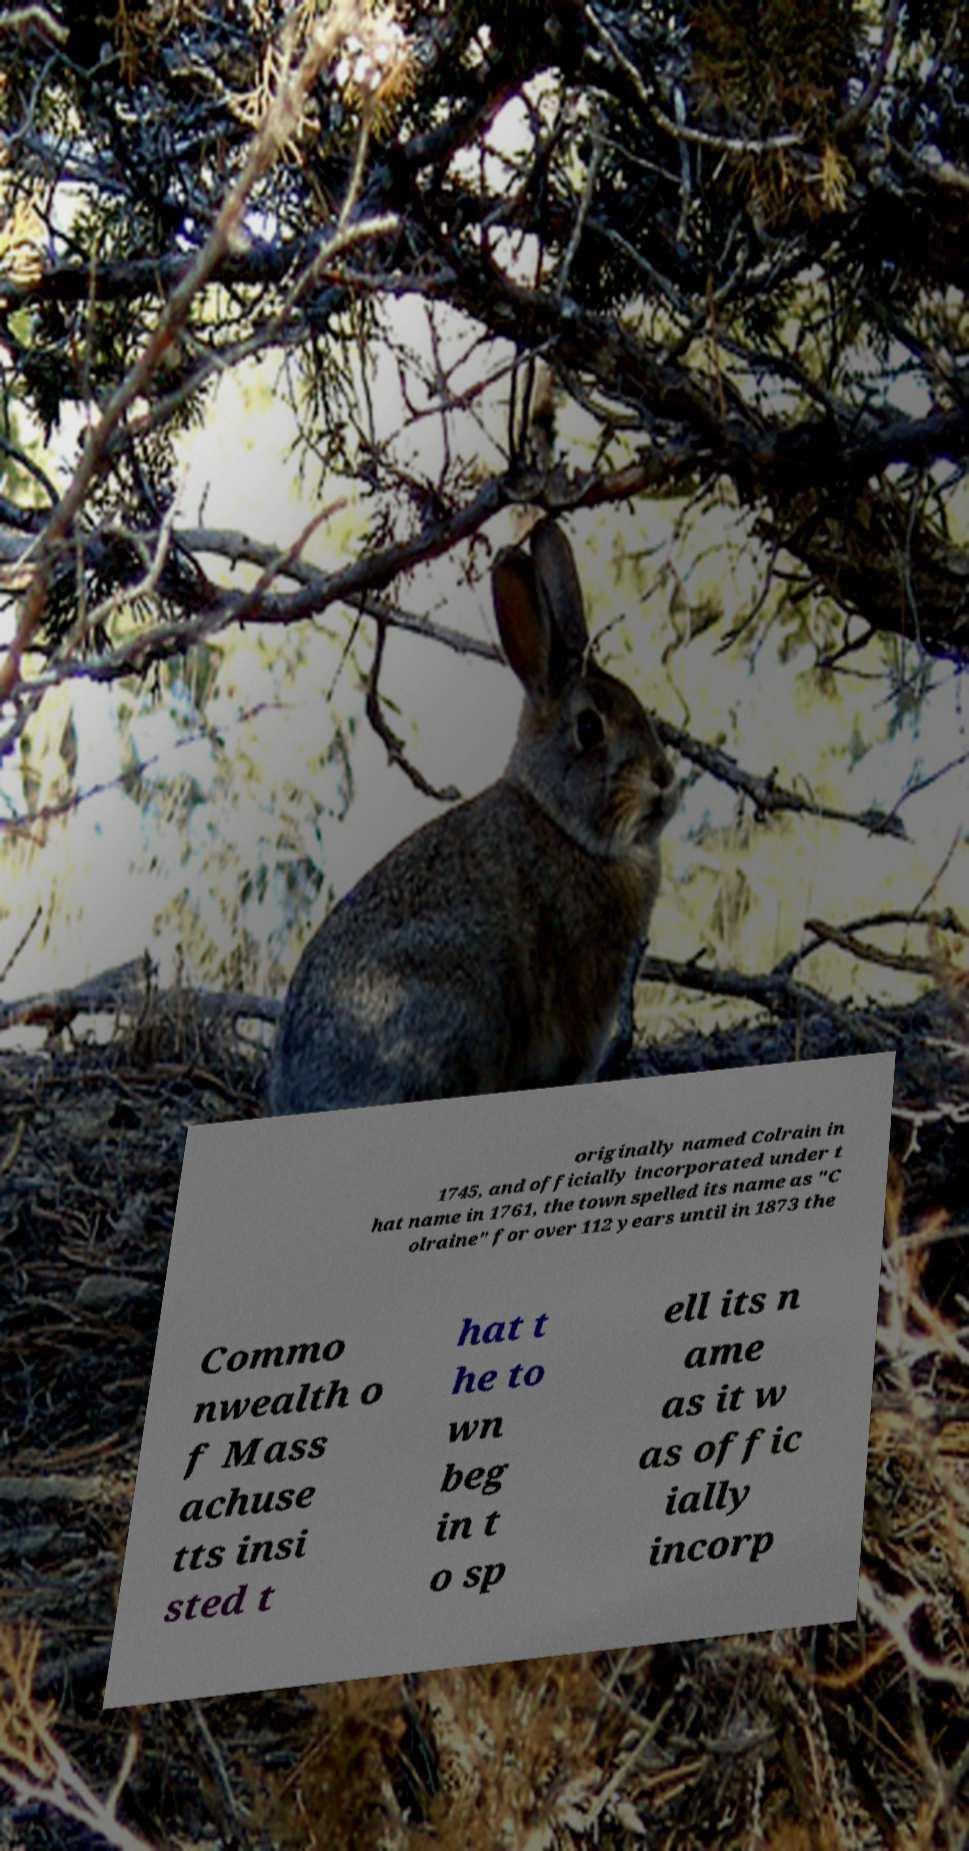Can you accurately transcribe the text from the provided image for me? originally named Colrain in 1745, and officially incorporated under t hat name in 1761, the town spelled its name as "C olraine" for over 112 years until in 1873 the Commo nwealth o f Mass achuse tts insi sted t hat t he to wn beg in t o sp ell its n ame as it w as offic ially incorp 